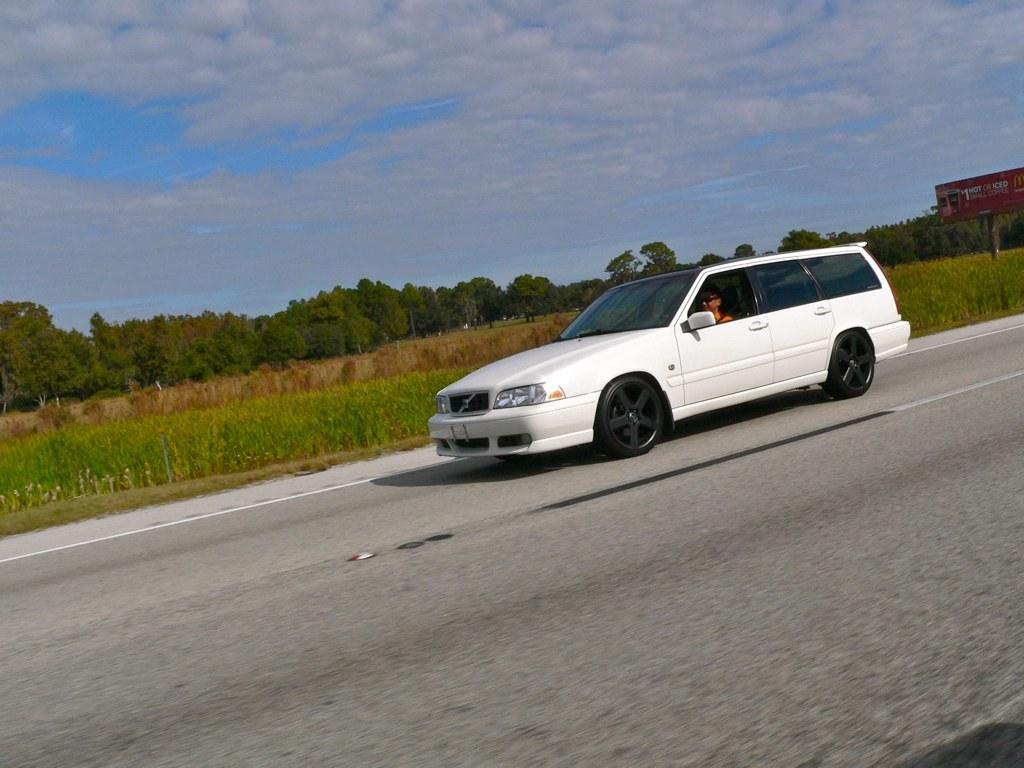What is located on the right side of the image? There is a person in a car on the right side of the image. What can be seen in the background of the image? There is greenery and a sign board in the background of the image. What is visible in the sky in the image? The sky is visible in the background of the image. What type of seed can be seen growing in the middle of the image? There is no seed or plant visible in the middle of the image. 